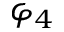Convert formula to latex. <formula><loc_0><loc_0><loc_500><loc_500>\varphi _ { 4 }</formula> 